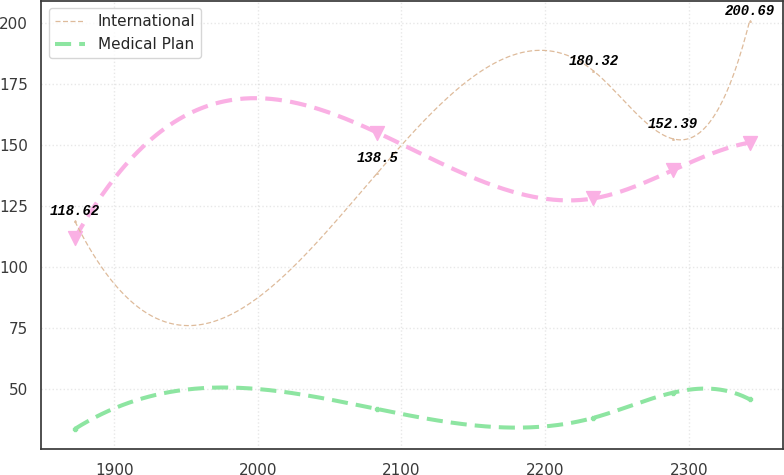Convert chart to OTSL. <chart><loc_0><loc_0><loc_500><loc_500><line_chart><ecel><fcel>Unnamed: 1<fcel>International<fcel>Medical Plan<nl><fcel>1872.67<fcel>111.69<fcel>118.62<fcel>33.49<nl><fcel>2083.28<fcel>154.95<fcel>138.5<fcel>41.62<nl><fcel>2233.6<fcel>127.98<fcel>180.32<fcel>38.03<nl><fcel>2289.14<fcel>139.61<fcel>152.39<fcel>48.37<nl><fcel>2342.37<fcel>150.9<fcel>200.69<fcel>45.63<nl></chart> 